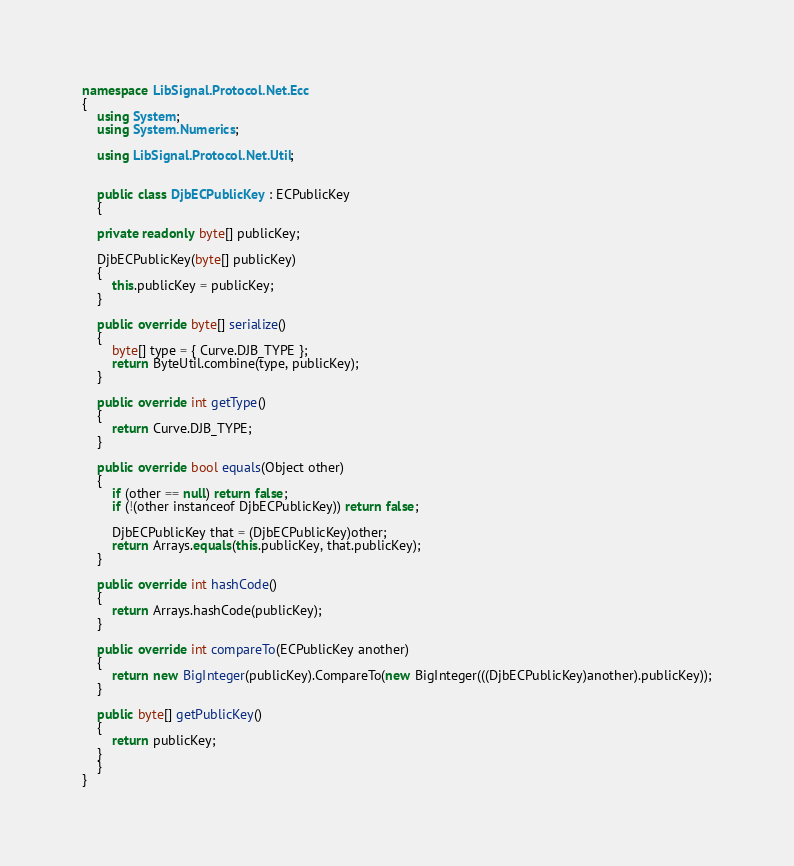Convert code to text. <code><loc_0><loc_0><loc_500><loc_500><_C#_>namespace LibSignal.Protocol.Net.Ecc
{
    using System;
    using System.Numerics;

    using LibSignal.Protocol.Net.Util;


    public class DjbECPublicKey : ECPublicKey
    {

    private readonly byte[] publicKey;

    DjbECPublicKey(byte[] publicKey)
    {
        this.publicKey = publicKey;
    }

    public override byte[] serialize()
    {
        byte[] type = { Curve.DJB_TYPE };
        return ByteUtil.combine(type, publicKey);
    }

    public override int getType()
    {
        return Curve.DJB_TYPE;
    }

    public override bool equals(Object other)
    {
        if (other == null) return false;
        if (!(other instanceof DjbECPublicKey)) return false;

        DjbECPublicKey that = (DjbECPublicKey)other;
        return Arrays.equals(this.publicKey, that.publicKey);
    }

    public override int hashCode()
    {
        return Arrays.hashCode(publicKey);
    }

    public override int compareTo(ECPublicKey another)
    {
        return new BigInteger(publicKey).CompareTo(new BigInteger(((DjbECPublicKey)another).publicKey));
    }

    public byte[] getPublicKey()
    {
        return publicKey;
    }
    }
}</code> 